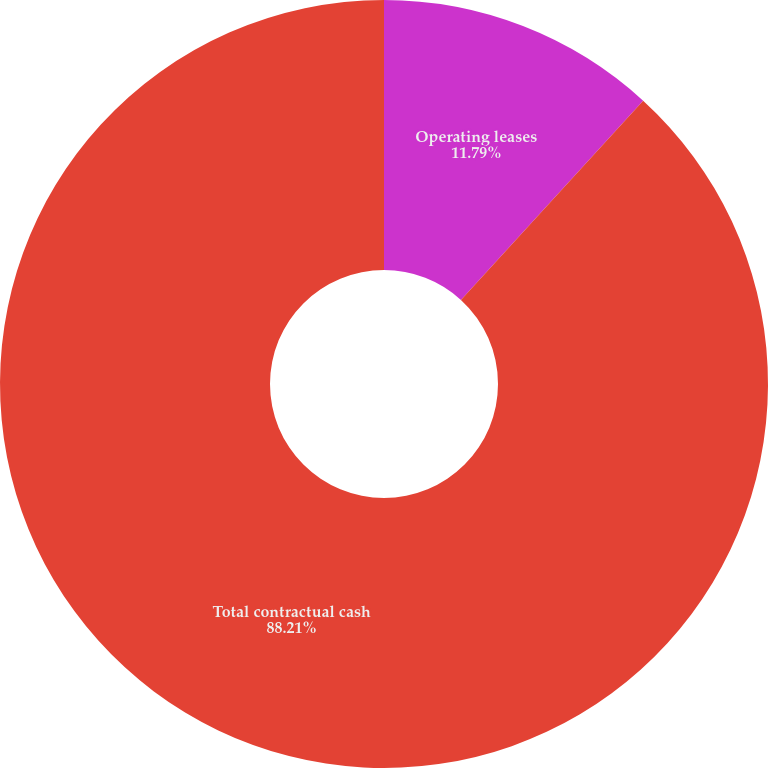<chart> <loc_0><loc_0><loc_500><loc_500><pie_chart><fcel>Operating leases<fcel>Total contractual cash<nl><fcel>11.79%<fcel>88.21%<nl></chart> 